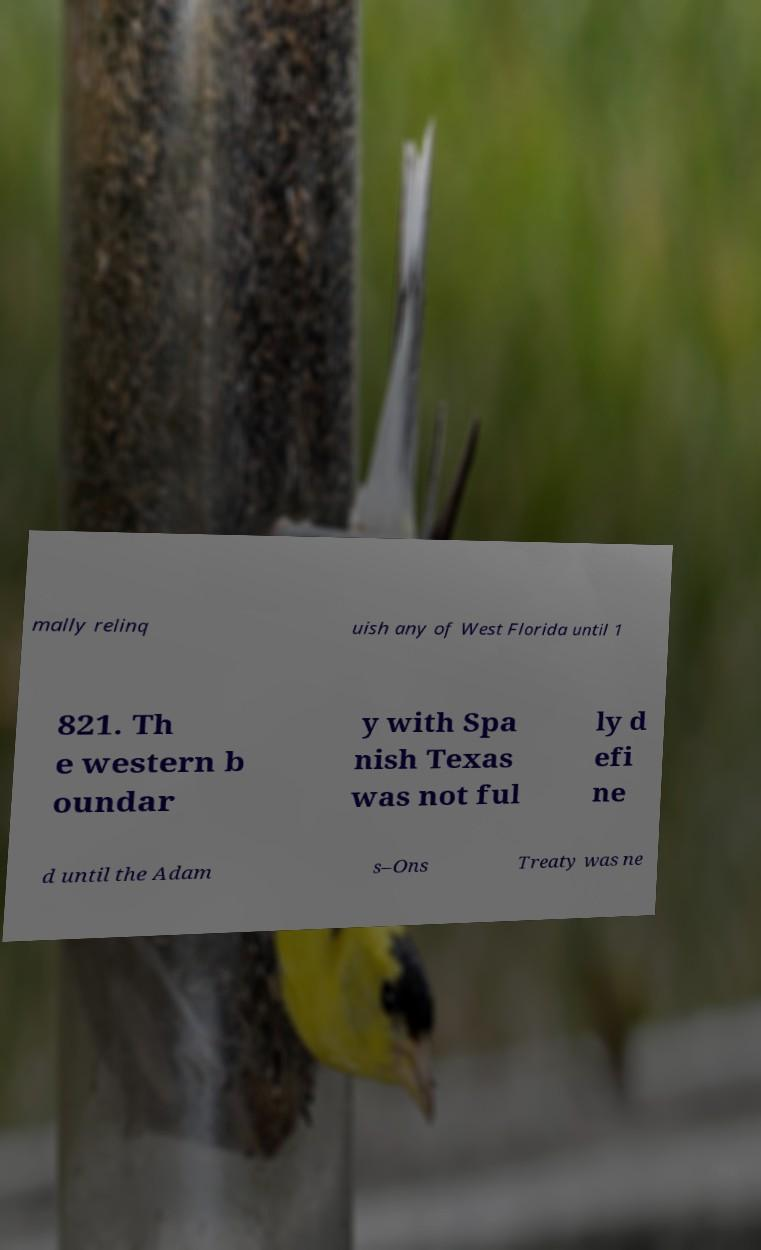Please identify and transcribe the text found in this image. mally relinq uish any of West Florida until 1 821. Th e western b oundar y with Spa nish Texas was not ful ly d efi ne d until the Adam s–Ons Treaty was ne 